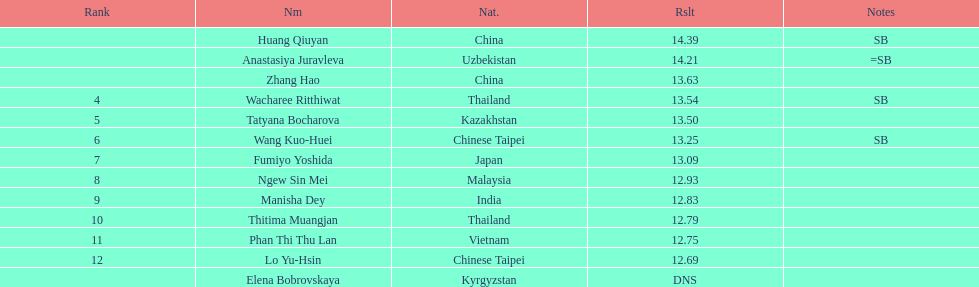How many points apart were the 1st place competitor and the 12th place competitor? 1.7. 